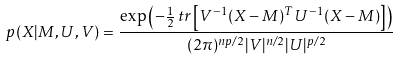<formula> <loc_0><loc_0><loc_500><loc_500>p ( X | M , U , V ) = { \frac { \exp \left ( - { \frac { 1 } { 2 } } \, t r \left [ V ^ { - 1 } ( X - M ) ^ { T } U ^ { - 1 } ( X - M ) \right ] \right ) } { ( 2 \pi ) ^ { n p / 2 } | V | ^ { n / 2 } | U | ^ { p / 2 } } }</formula> 